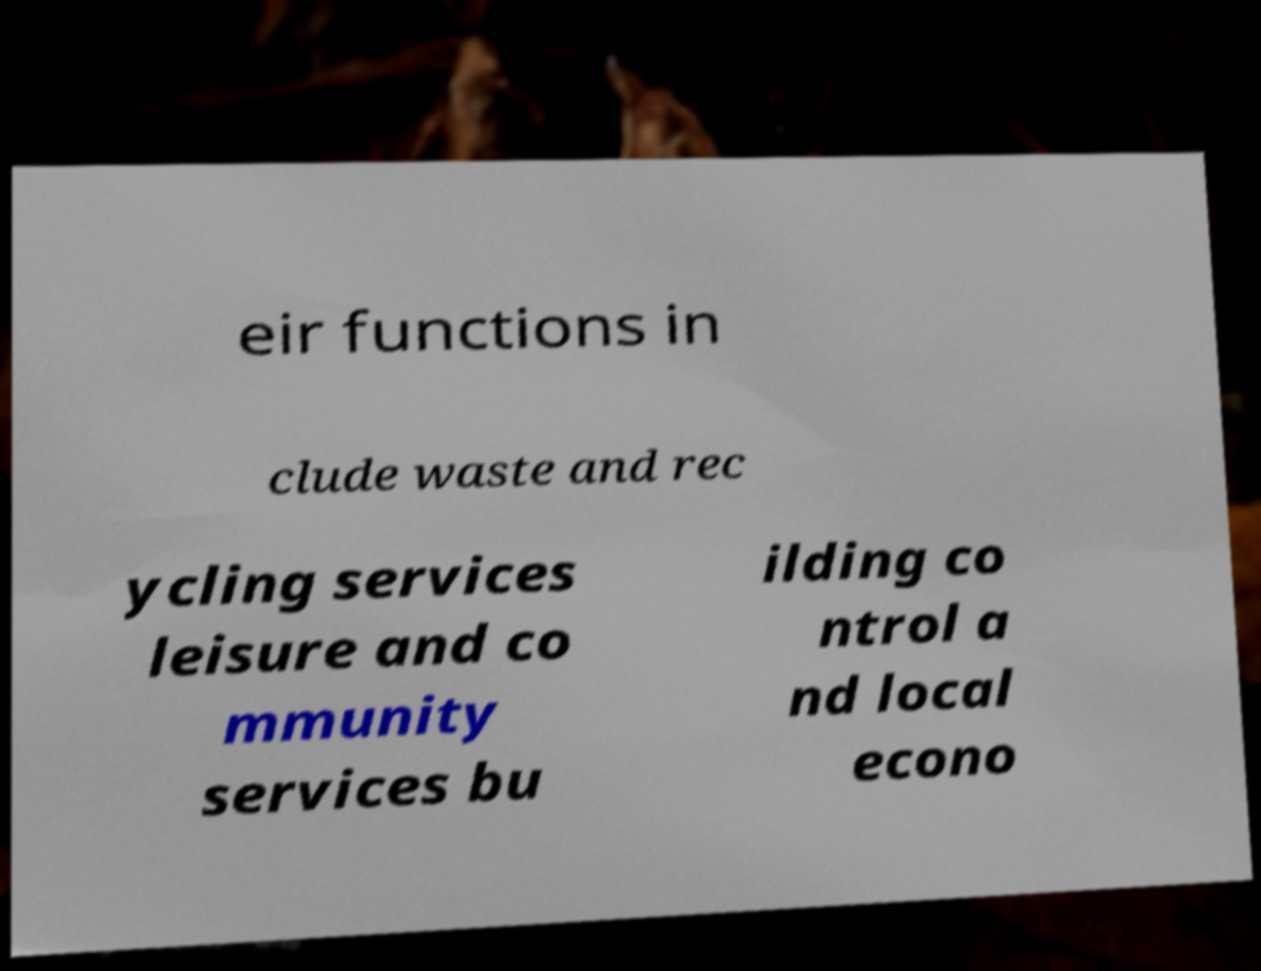Please identify and transcribe the text found in this image. eir functions in clude waste and rec ycling services leisure and co mmunity services bu ilding co ntrol a nd local econo 